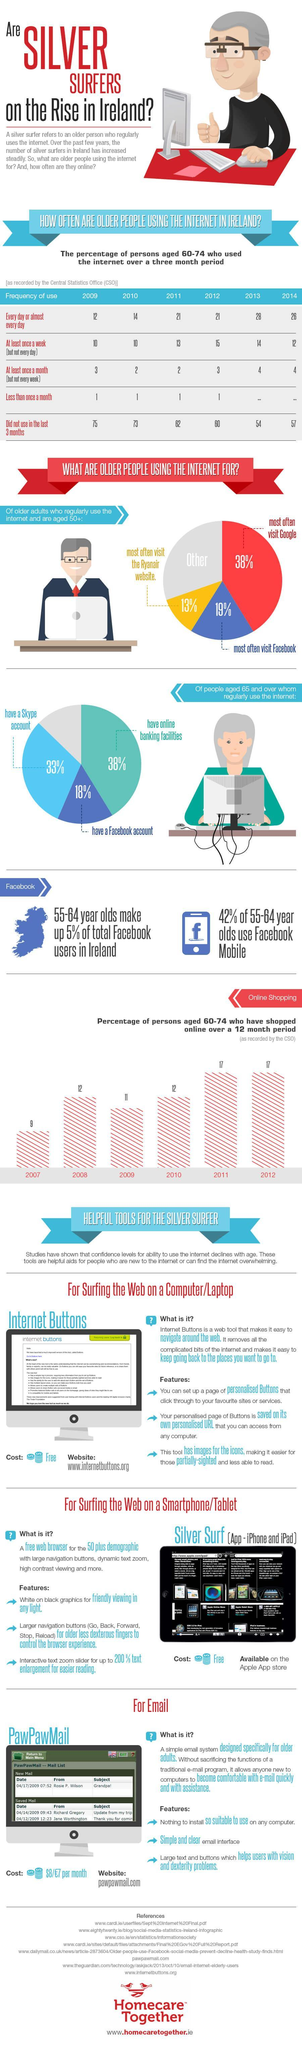Which year has the usage by the age group of 60+ who use it atleast once a week been the highest
Answer the question with a short phrase. 2012 Which are the tools which are easy for the silver surfer while using a computer/laptop, smartphone/tablet or email Internet Buttons, Silver Surf, PawPawMail What has been the rise in numbers in silver surfers on daily usage from 2009 to 2014 14 Which years has the % of persons aged 60-74 who have shopped online  been at 17 2011, 2012 How much in dollars in the monthly charge for PawPawMail $8 What % of senior citizens who regularly use the internet have a skype account 33% When was the frequency of use every day or almost every day the highest 2013 Which years has the % of persons aged 60-74 who have shopped online  been at 12 2008, 2010 What % of people use the internet for FB and Google 57 